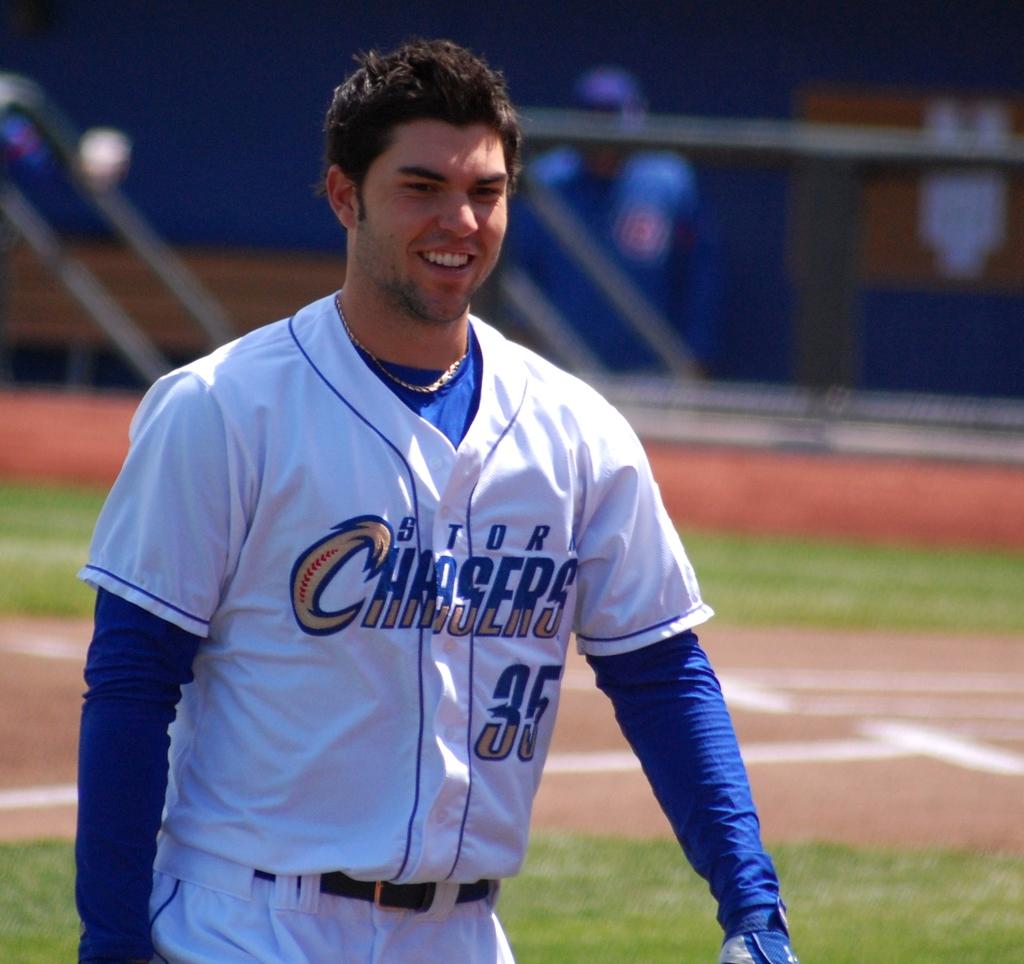What is the player's number?
Offer a terse response. 35. 